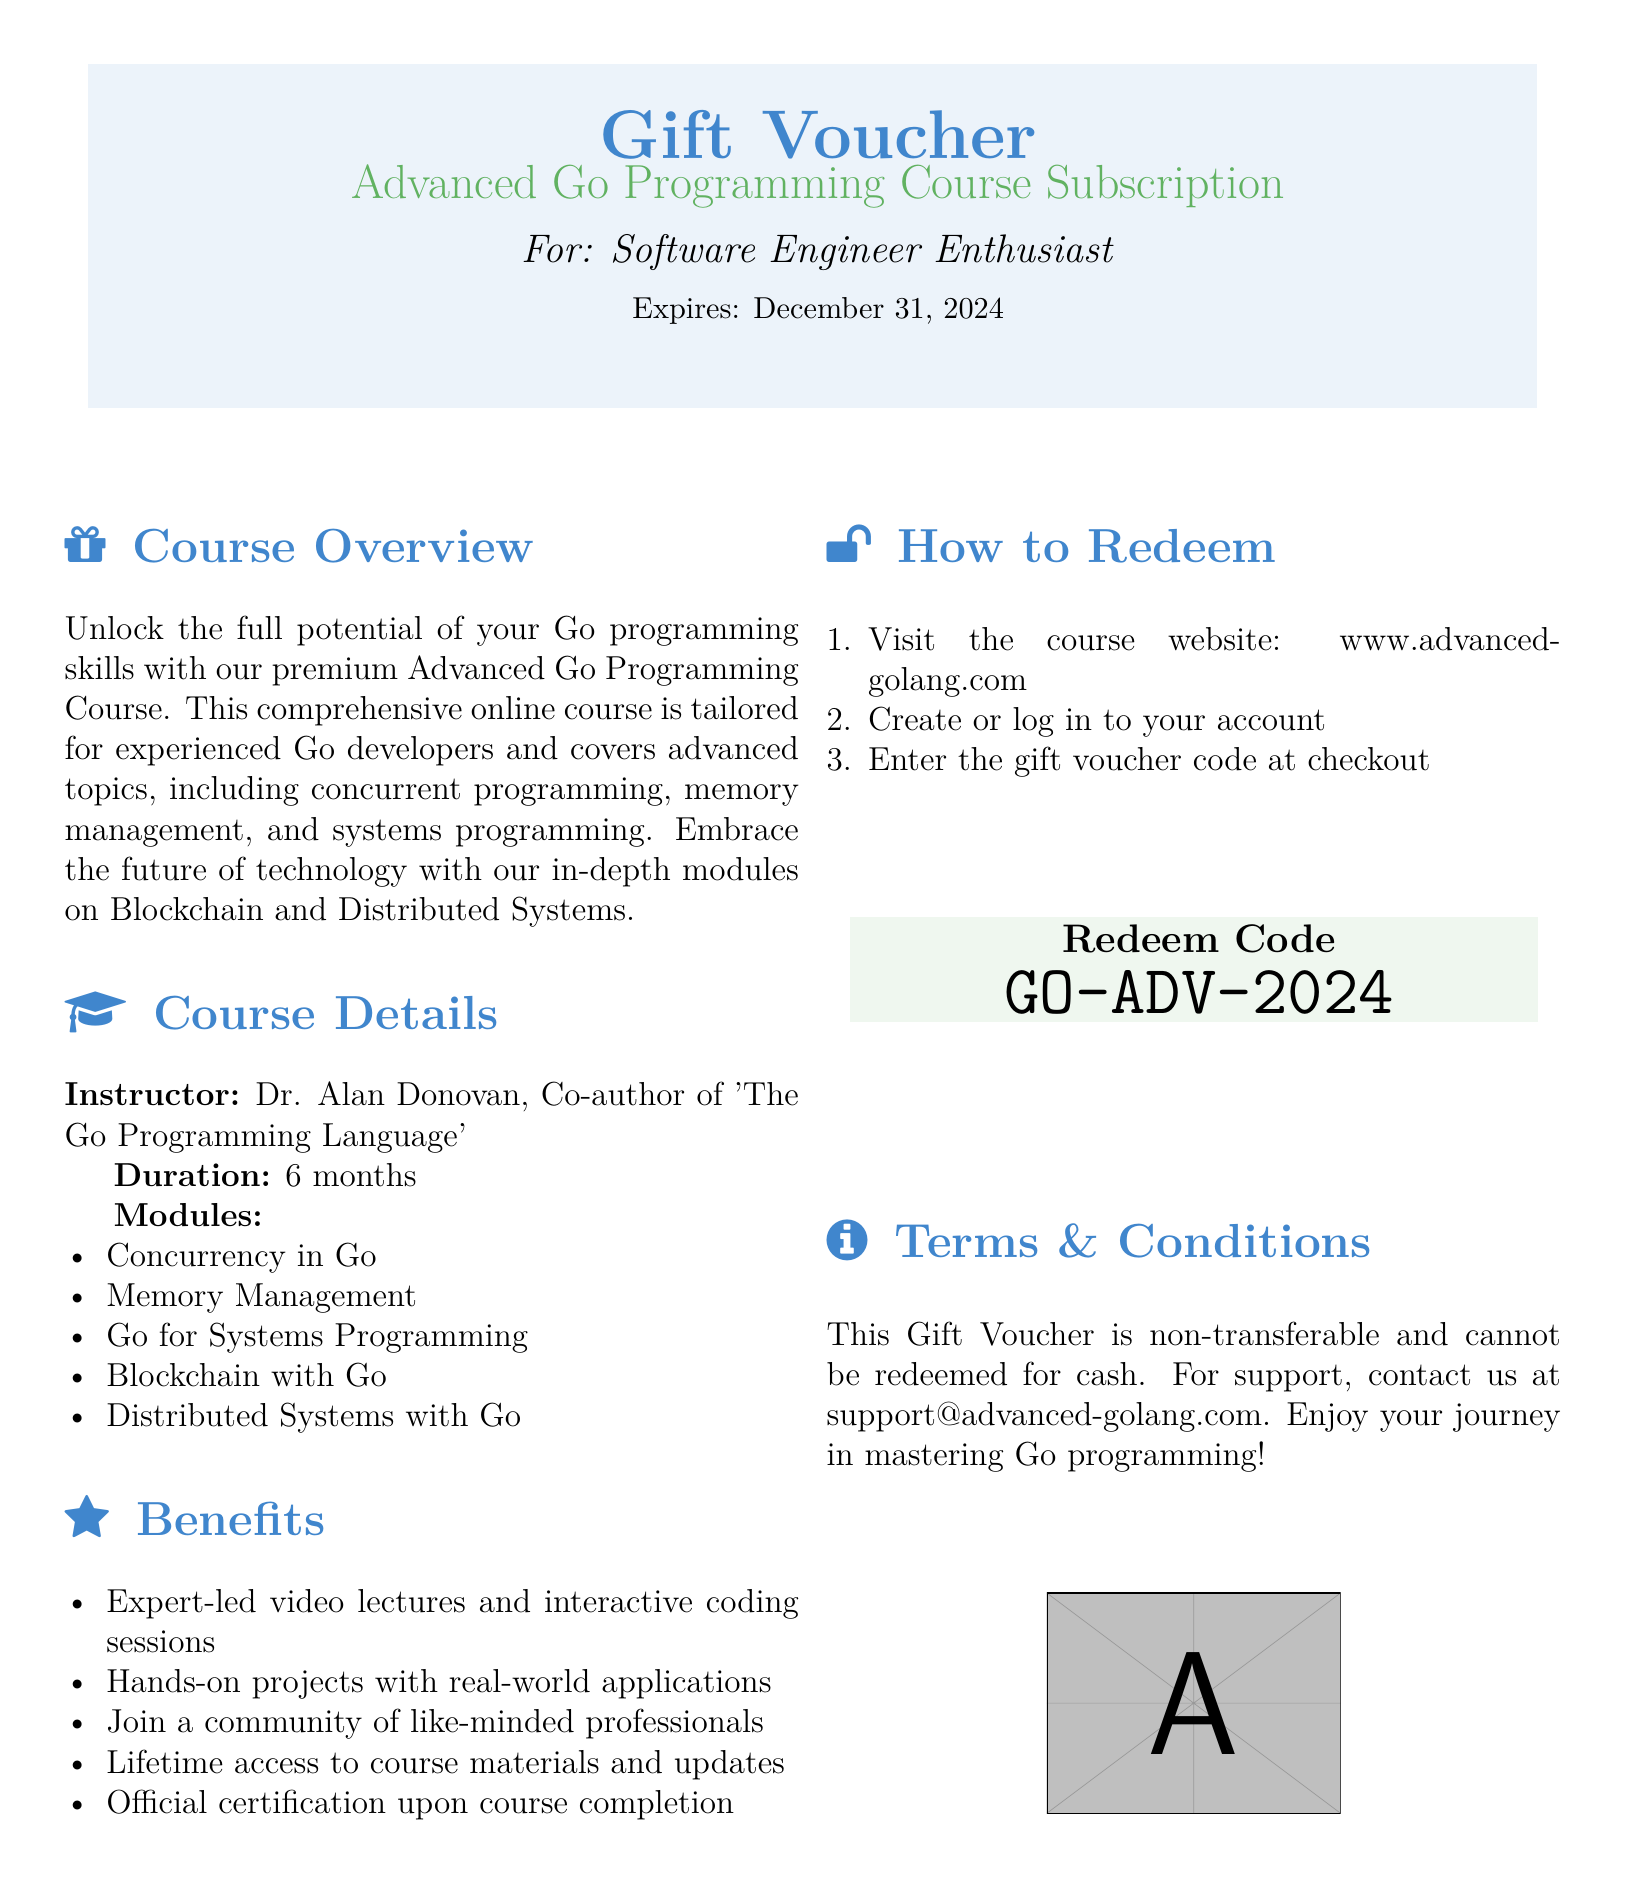What is the title of the course? The title of the course is mentioned at the top of the document, indicating it focuses on advanced Go programming skills.
Answer: Advanced Go Programming Course Subscription Who is the instructor of the course? The document specifically names Dr. Alan Donovan as the instructor, highlighting his contribution to the Go programming language literature.
Answer: Dr. Alan Donovan What is the duration of the course? The duration of the course is clearly stated in the document under the course details section.
Answer: 6 months What is the expiration date of the gift voucher? The expiration date of the gift voucher is mentioned directly in the introductory section.
Answer: December 31, 2024 What type of access is provided to course materials? The document lists a benefit that clearly indicates the type of access provided to the course materials.
Answer: Lifetime access How can the course be redeemed? The steps to redeem the course are outlined in the document listing the process to follow on the course's website.
Answer: Visit the course website What is the redeem code? The redeem code is presented in a designated area of the document and is needed to access the course subscription.
Answer: GO-ADV-2024 What is the primary focus of the course content? The course overview describes the primary focus areas that the course will cover, including advanced topics in Go programming.
Answer: Concurrent programming, memory management, and systems programming What is the email for support? The contact method for support is provided at the end of the document, indicating where to seek help regarding the voucher.
Answer: support@advanced-golang.com 